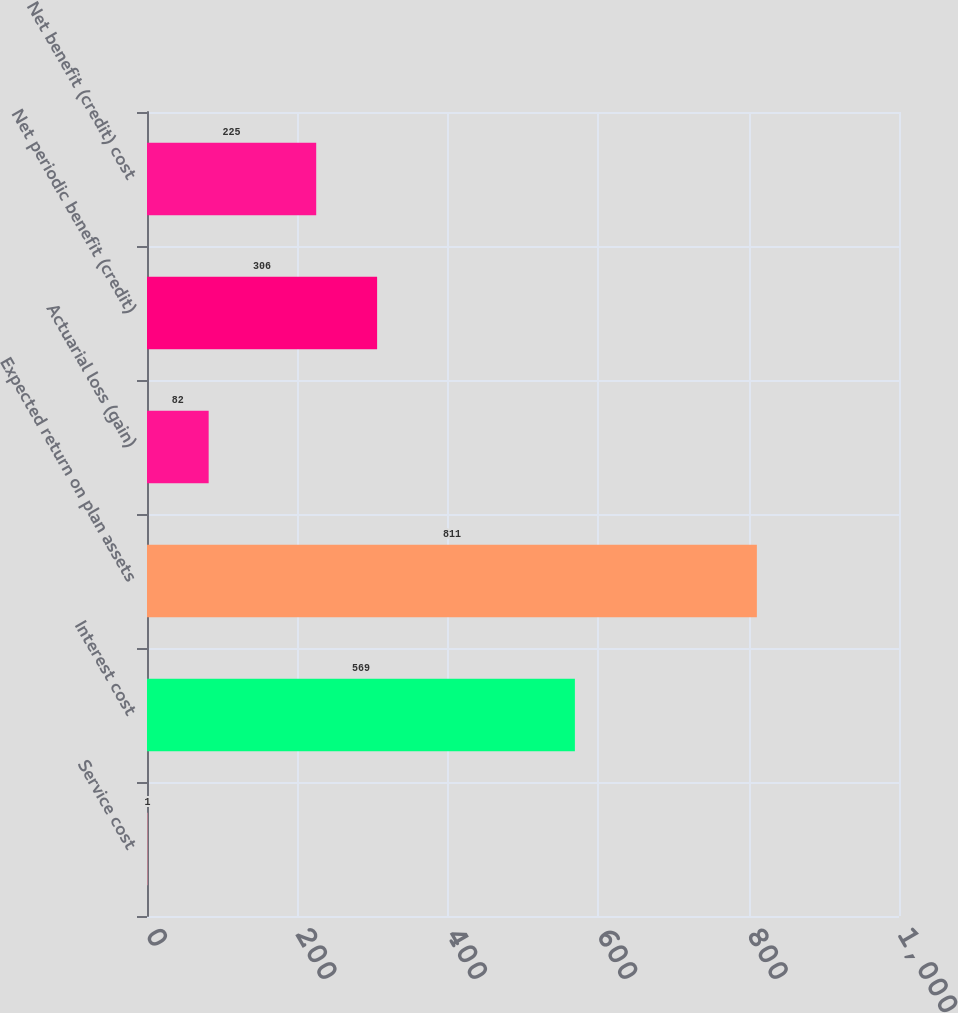Convert chart to OTSL. <chart><loc_0><loc_0><loc_500><loc_500><bar_chart><fcel>Service cost<fcel>Interest cost<fcel>Expected return on plan assets<fcel>Actuarial loss (gain)<fcel>Net periodic benefit (credit)<fcel>Net benefit (credit) cost<nl><fcel>1<fcel>569<fcel>811<fcel>82<fcel>306<fcel>225<nl></chart> 